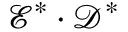Convert formula to latex. <formula><loc_0><loc_0><loc_500><loc_500>\mathcal { E } ^ { * } \cdot \mathcal { D } ^ { * }</formula> 